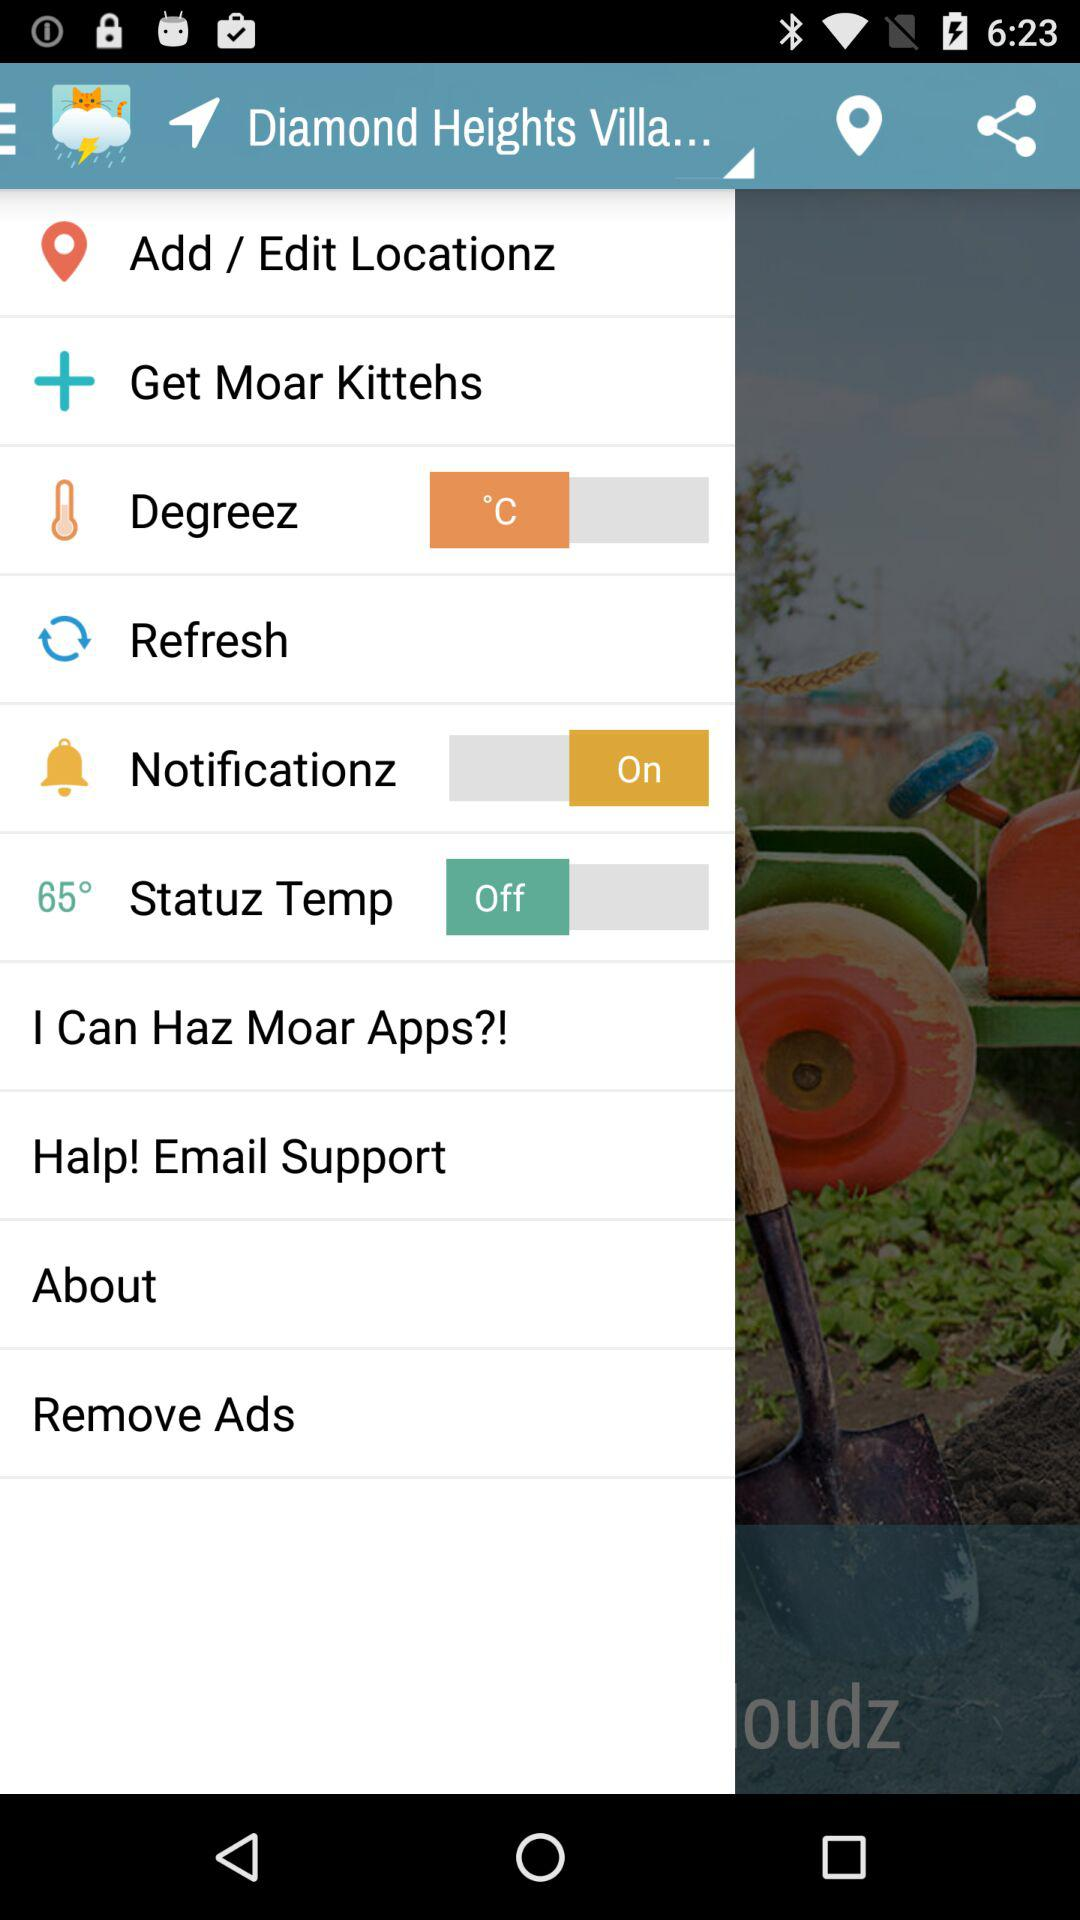What is the unit of degreez? The unit of degreez is °C. 